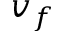Convert formula to latex. <formula><loc_0><loc_0><loc_500><loc_500>v _ { f }</formula> 